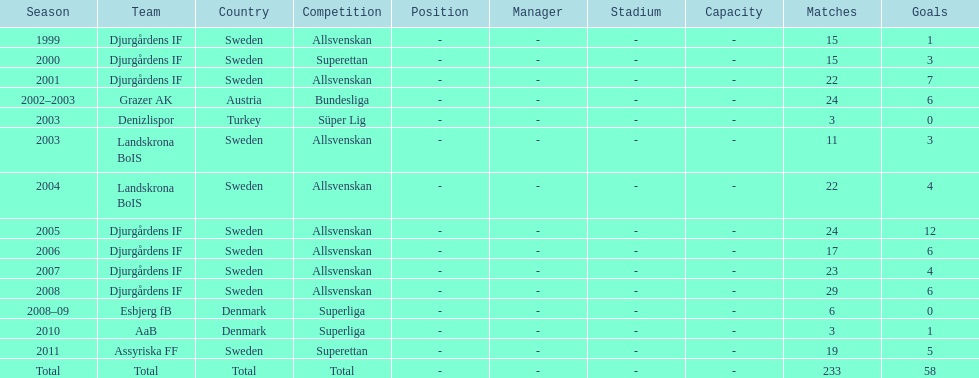How many total goals has jones kusi-asare scored? 58. 